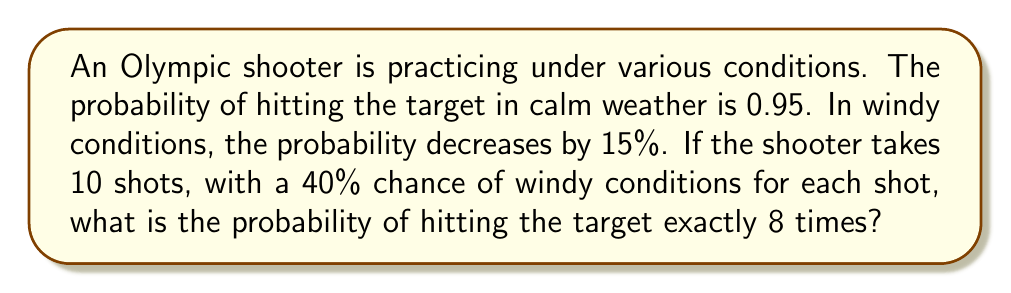Can you solve this math problem? Let's approach this step-by-step:

1) First, let's calculate the probabilities:
   - Probability of hitting in calm weather: $p_c = 0.95$
   - Probability of hitting in windy conditions: $p_w = 0.95 - (0.95 * 0.15) = 0.8075$
   - Probability of windy conditions: $w = 0.4$
   - Probability of calm conditions: $1 - w = 0.6$

2) For each shot, the probability of hitting the target is:
   $p = (p_c * (1-w)) + (p_w * w)$
   $p = (0.95 * 0.6) + (0.8075 * 0.4) = 0.893$

3) This scenario follows a binomial distribution. The probability of exactly 8 successes in 10 trials is given by:

   $$P(X=8) = \binom{10}{8} p^8 (1-p)^{10-8}$$

   Where $\binom{10}{8}$ is the binomial coefficient.

4) Calculate the binomial coefficient:
   $$\binom{10}{8} = \frac{10!}{8!(10-8)!} = \frac{10!}{8!2!} = 45$$

5) Now, let's substitute all values into the formula:
   $$P(X=8) = 45 * (0.893)^8 * (1-0.893)^2$$
   $$= 45 * (0.893)^8 * (0.107)^2$$

6) Calculate the final result:
   $$= 45 * 0.4284 * 0.0114 = 0.2201$$
Answer: The probability of hitting the target exactly 8 times out of 10 shots under the given conditions is approximately 0.2201 or 22.01%. 